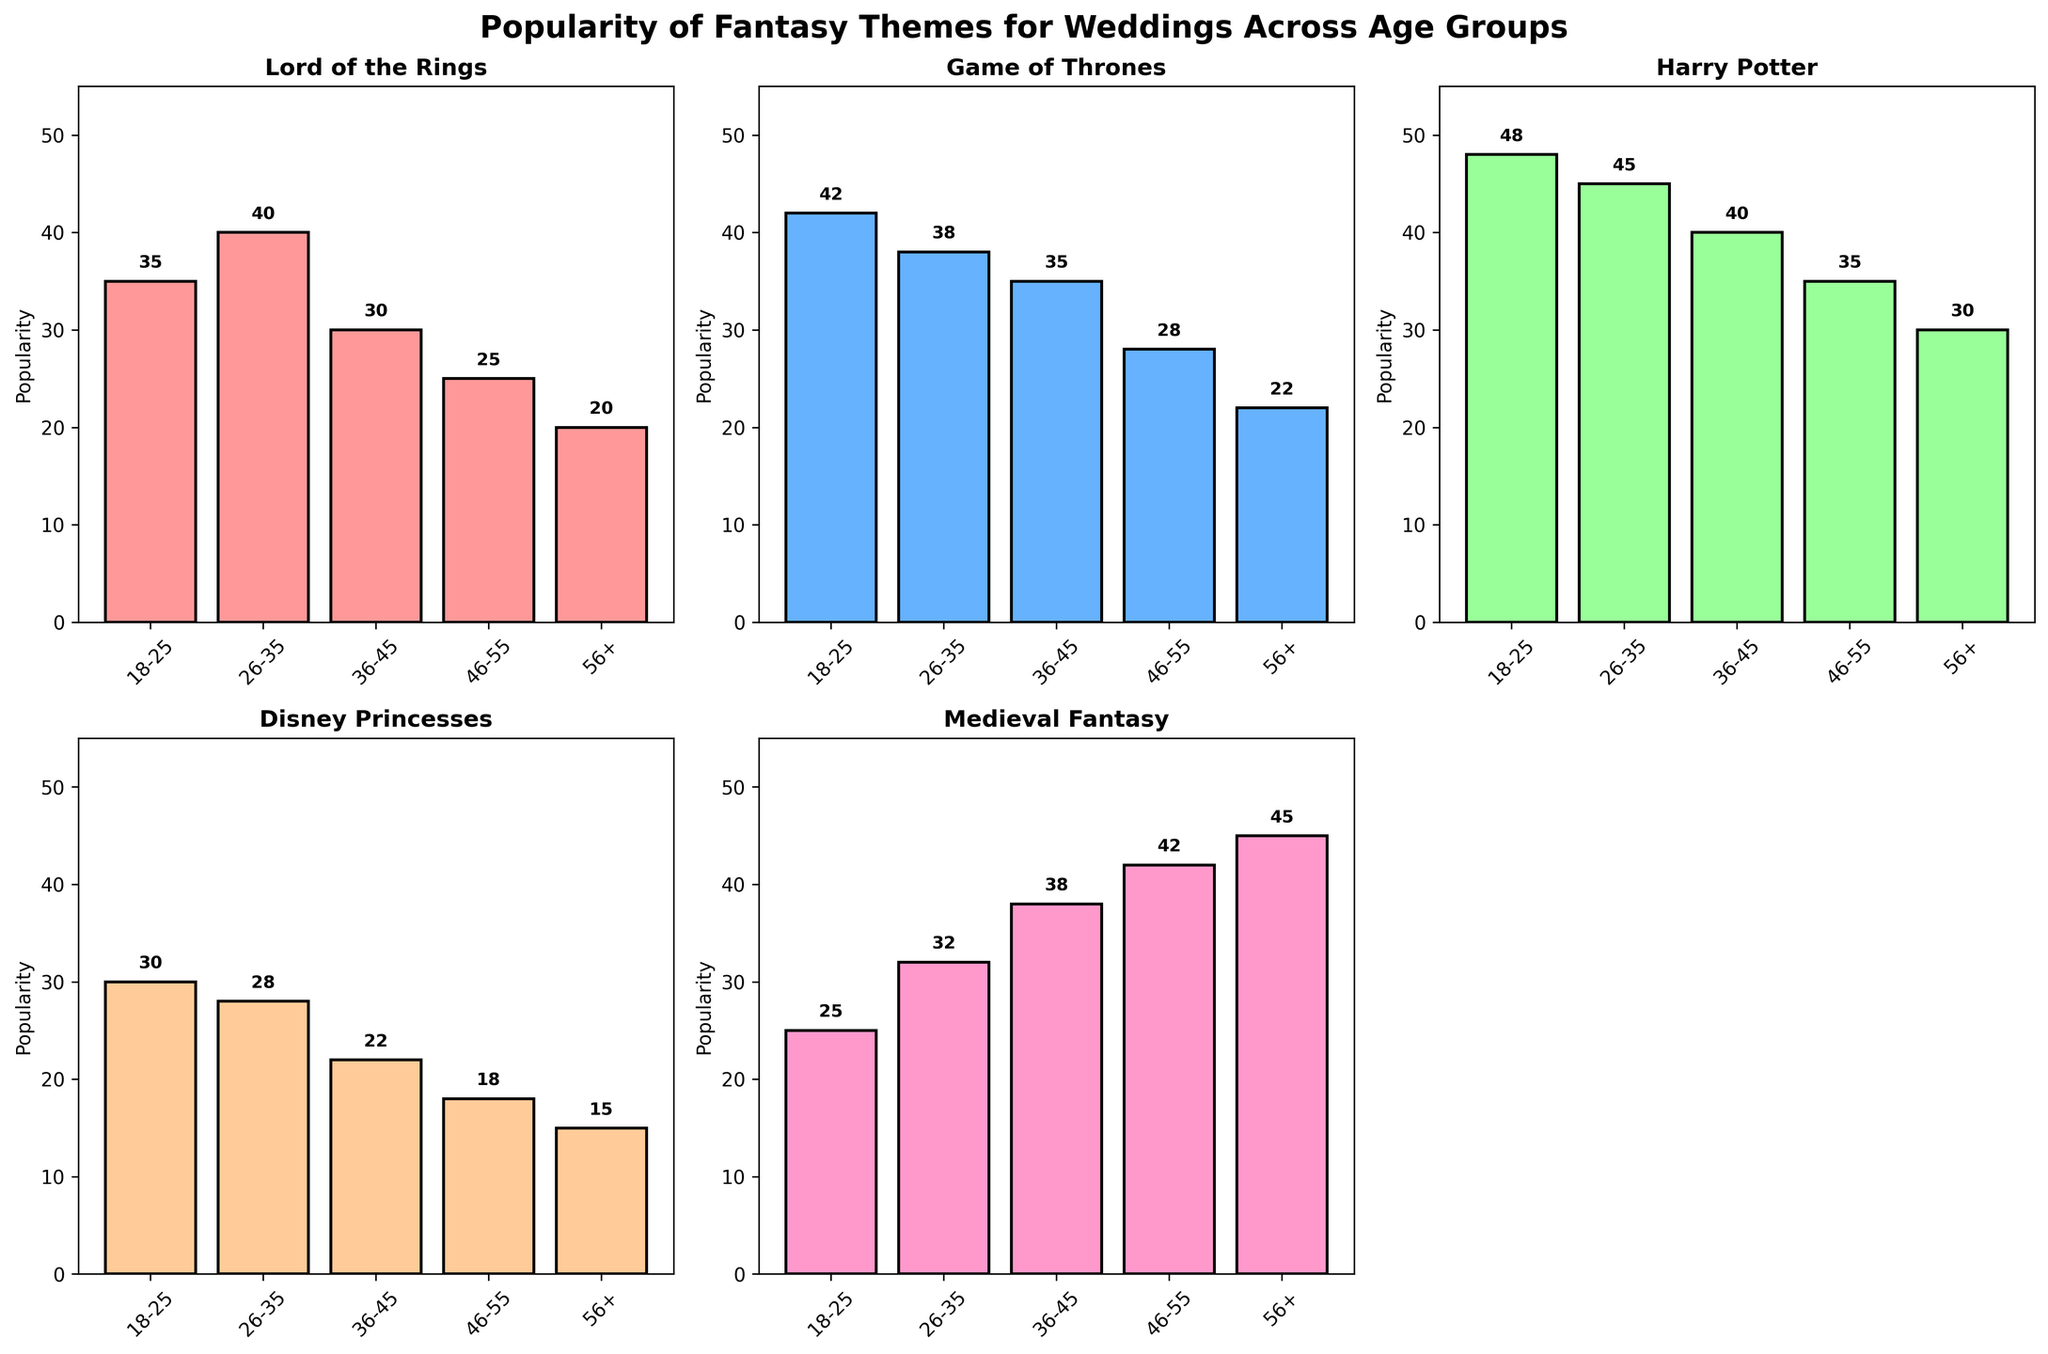What age group prefers Game of Thrones the most? From looking at the bar heights, the 18-25 age group has the highest bar for Game of Thrones, indicating the greatest popularity.
Answer: 18-25 Which theme has the least popularity among the 46-55 age group? In the 46-55 age group, Disney Princesses has the smallest bar, indicating it is the least popular theme.
Answer: Disney Princesses Between Medieval Fantasy and Harry Potter, which theme is more popular among the 36-45 age group? Comparing the bar heights for the 36-45 age group, Medieval Fantasy has a taller bar than Harry Potter.
Answer: Medieval Fantasy What is the average popularity of the Disney Princesses theme across all age groups? To find the average, sum the popularity values for Disney Princesses (30 + 28 + 22 + 18 + 15) and divide by 5. (30 + 28 + 22 + 18 + 15) / 5 = 113 / 5
Answer: 22.6 Which age group has the highest popularity for Medieval Fantasy? The age group with the tallest bar for Medieval Fantasy is 56+, indicating the highest popularity.
Answer: 56+ How does the popularity of Lord of the Rings compare between the 18-25 and 26-35 age groups? Comparing the Lord of the Rings bars in the 18-25 and 26-35 age groups, the 26-35 group has a slightly taller bar, showing higher popularity.
Answer: 26-35 What is the title of the figure? The title is displayed at the top of the figure: "Popularity of Fantasy Themes for Weddings Across Age Groups".
Answer: Popularity of Fantasy Themes for Weddings Across Age Groups Which theme shows a decreasing trend in popularity as the age group increases? By observing the trend in bar heights for each theme, it's noticeable that Harry Potter shows a general decreasing trend from the 18-25 age group up to 56+.
Answer: Harry Potter What is the total popularity score for Disney Princesses and Medieval Fantasy combined in the 56+ age group? Adding the values for Disney Princesses (15) and Medieval Fantasy (45) in the 56+ age group gives 15 + 45 = 60.
Answer: 60 